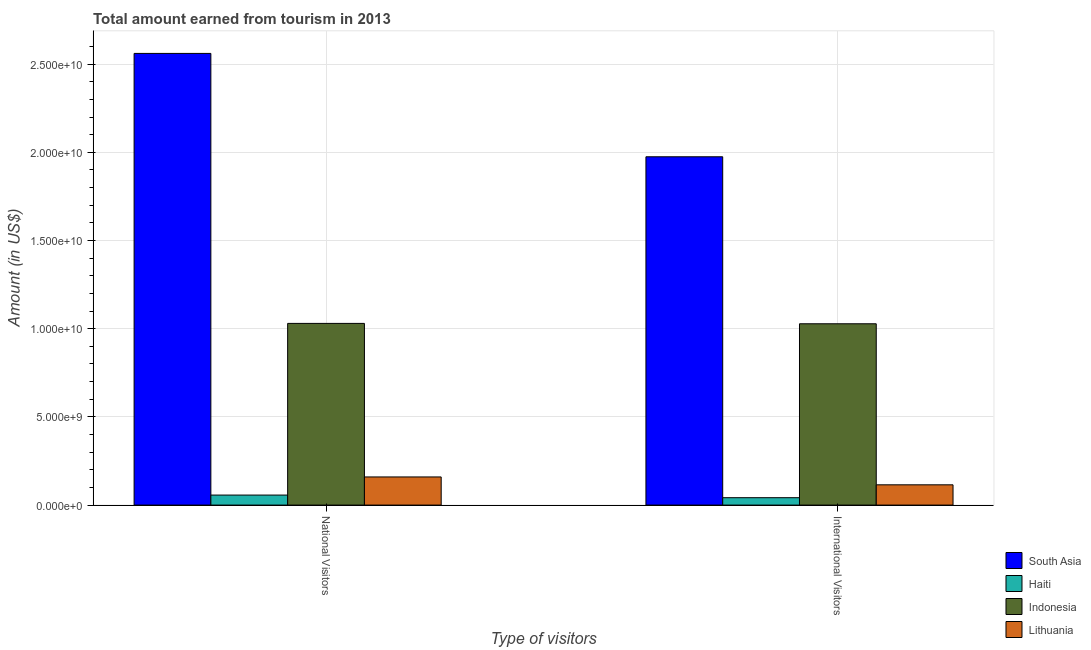How many different coloured bars are there?
Your response must be concise. 4. Are the number of bars on each tick of the X-axis equal?
Offer a very short reply. Yes. How many bars are there on the 1st tick from the right?
Ensure brevity in your answer.  4. What is the label of the 1st group of bars from the left?
Provide a succinct answer. National Visitors. What is the amount earned from national visitors in Haiti?
Keep it short and to the point. 5.68e+08. Across all countries, what is the maximum amount earned from national visitors?
Your answer should be compact. 2.56e+1. Across all countries, what is the minimum amount earned from international visitors?
Ensure brevity in your answer.  4.19e+08. In which country was the amount earned from national visitors maximum?
Make the answer very short. South Asia. In which country was the amount earned from international visitors minimum?
Make the answer very short. Haiti. What is the total amount earned from national visitors in the graph?
Ensure brevity in your answer.  3.81e+1. What is the difference between the amount earned from national visitors in South Asia and that in Lithuania?
Provide a short and direct response. 2.40e+1. What is the difference between the amount earned from international visitors in Lithuania and the amount earned from national visitors in Indonesia?
Make the answer very short. -9.15e+09. What is the average amount earned from international visitors per country?
Offer a terse response. 7.90e+09. What is the difference between the amount earned from international visitors and amount earned from national visitors in Haiti?
Your answer should be compact. -1.49e+08. What is the ratio of the amount earned from national visitors in Lithuania to that in Haiti?
Your response must be concise. 2.81. In how many countries, is the amount earned from national visitors greater than the average amount earned from national visitors taken over all countries?
Offer a very short reply. 2. What does the 4th bar from the right in National Visitors represents?
Give a very brief answer. South Asia. How many bars are there?
Your response must be concise. 8. Are the values on the major ticks of Y-axis written in scientific E-notation?
Offer a very short reply. Yes. Does the graph contain grids?
Provide a short and direct response. Yes. How are the legend labels stacked?
Ensure brevity in your answer.  Vertical. What is the title of the graph?
Give a very brief answer. Total amount earned from tourism in 2013. Does "East Asia (all income levels)" appear as one of the legend labels in the graph?
Your answer should be very brief. No. What is the label or title of the X-axis?
Your response must be concise. Type of visitors. What is the Amount (in US$) in South Asia in National Visitors?
Make the answer very short. 2.56e+1. What is the Amount (in US$) in Haiti in National Visitors?
Offer a very short reply. 5.68e+08. What is the Amount (in US$) of Indonesia in National Visitors?
Provide a succinct answer. 1.03e+1. What is the Amount (in US$) in Lithuania in National Visitors?
Your answer should be very brief. 1.60e+09. What is the Amount (in US$) in South Asia in International Visitors?
Your response must be concise. 1.97e+1. What is the Amount (in US$) in Haiti in International Visitors?
Offer a terse response. 4.19e+08. What is the Amount (in US$) in Indonesia in International Visitors?
Ensure brevity in your answer.  1.03e+1. What is the Amount (in US$) in Lithuania in International Visitors?
Give a very brief answer. 1.15e+09. Across all Type of visitors, what is the maximum Amount (in US$) of South Asia?
Your answer should be very brief. 2.56e+1. Across all Type of visitors, what is the maximum Amount (in US$) in Haiti?
Your answer should be very brief. 5.68e+08. Across all Type of visitors, what is the maximum Amount (in US$) of Indonesia?
Your answer should be very brief. 1.03e+1. Across all Type of visitors, what is the maximum Amount (in US$) in Lithuania?
Your answer should be compact. 1.60e+09. Across all Type of visitors, what is the minimum Amount (in US$) in South Asia?
Offer a terse response. 1.97e+1. Across all Type of visitors, what is the minimum Amount (in US$) in Haiti?
Your response must be concise. 4.19e+08. Across all Type of visitors, what is the minimum Amount (in US$) of Indonesia?
Your answer should be compact. 1.03e+1. Across all Type of visitors, what is the minimum Amount (in US$) of Lithuania?
Offer a very short reply. 1.15e+09. What is the total Amount (in US$) in South Asia in the graph?
Your response must be concise. 4.54e+1. What is the total Amount (in US$) of Haiti in the graph?
Your response must be concise. 9.87e+08. What is the total Amount (in US$) of Indonesia in the graph?
Your answer should be compact. 2.06e+1. What is the total Amount (in US$) of Lithuania in the graph?
Offer a terse response. 2.74e+09. What is the difference between the Amount (in US$) of South Asia in National Visitors and that in International Visitors?
Make the answer very short. 5.86e+09. What is the difference between the Amount (in US$) in Haiti in National Visitors and that in International Visitors?
Give a very brief answer. 1.49e+08. What is the difference between the Amount (in US$) of Indonesia in National Visitors and that in International Visitors?
Provide a succinct answer. 2.20e+07. What is the difference between the Amount (in US$) of Lithuania in National Visitors and that in International Visitors?
Provide a succinct answer. 4.46e+08. What is the difference between the Amount (in US$) of South Asia in National Visitors and the Amount (in US$) of Haiti in International Visitors?
Give a very brief answer. 2.52e+1. What is the difference between the Amount (in US$) in South Asia in National Visitors and the Amount (in US$) in Indonesia in International Visitors?
Offer a very short reply. 1.53e+1. What is the difference between the Amount (in US$) of South Asia in National Visitors and the Amount (in US$) of Lithuania in International Visitors?
Your answer should be very brief. 2.45e+1. What is the difference between the Amount (in US$) in Haiti in National Visitors and the Amount (in US$) in Indonesia in International Visitors?
Your answer should be compact. -9.71e+09. What is the difference between the Amount (in US$) of Haiti in National Visitors and the Amount (in US$) of Lithuania in International Visitors?
Ensure brevity in your answer.  -5.81e+08. What is the difference between the Amount (in US$) in Indonesia in National Visitors and the Amount (in US$) in Lithuania in International Visitors?
Provide a short and direct response. 9.15e+09. What is the average Amount (in US$) of South Asia per Type of visitors?
Your answer should be very brief. 2.27e+1. What is the average Amount (in US$) of Haiti per Type of visitors?
Make the answer very short. 4.94e+08. What is the average Amount (in US$) in Indonesia per Type of visitors?
Provide a succinct answer. 1.03e+1. What is the average Amount (in US$) of Lithuania per Type of visitors?
Provide a succinct answer. 1.37e+09. What is the difference between the Amount (in US$) of South Asia and Amount (in US$) of Haiti in National Visitors?
Provide a short and direct response. 2.50e+1. What is the difference between the Amount (in US$) in South Asia and Amount (in US$) in Indonesia in National Visitors?
Provide a short and direct response. 1.53e+1. What is the difference between the Amount (in US$) of South Asia and Amount (in US$) of Lithuania in National Visitors?
Your answer should be compact. 2.40e+1. What is the difference between the Amount (in US$) in Haiti and Amount (in US$) in Indonesia in National Visitors?
Make the answer very short. -9.73e+09. What is the difference between the Amount (in US$) of Haiti and Amount (in US$) of Lithuania in National Visitors?
Your answer should be very brief. -1.03e+09. What is the difference between the Amount (in US$) in Indonesia and Amount (in US$) in Lithuania in National Visitors?
Provide a succinct answer. 8.71e+09. What is the difference between the Amount (in US$) in South Asia and Amount (in US$) in Haiti in International Visitors?
Keep it short and to the point. 1.93e+1. What is the difference between the Amount (in US$) in South Asia and Amount (in US$) in Indonesia in International Visitors?
Offer a very short reply. 9.47e+09. What is the difference between the Amount (in US$) in South Asia and Amount (in US$) in Lithuania in International Visitors?
Provide a short and direct response. 1.86e+1. What is the difference between the Amount (in US$) of Haiti and Amount (in US$) of Indonesia in International Visitors?
Offer a very short reply. -9.86e+09. What is the difference between the Amount (in US$) of Haiti and Amount (in US$) of Lithuania in International Visitors?
Your response must be concise. -7.30e+08. What is the difference between the Amount (in US$) in Indonesia and Amount (in US$) in Lithuania in International Visitors?
Offer a very short reply. 9.13e+09. What is the ratio of the Amount (in US$) in South Asia in National Visitors to that in International Visitors?
Make the answer very short. 1.3. What is the ratio of the Amount (in US$) in Haiti in National Visitors to that in International Visitors?
Give a very brief answer. 1.36. What is the ratio of the Amount (in US$) in Lithuania in National Visitors to that in International Visitors?
Your answer should be compact. 1.39. What is the difference between the highest and the second highest Amount (in US$) in South Asia?
Your answer should be compact. 5.86e+09. What is the difference between the highest and the second highest Amount (in US$) in Haiti?
Keep it short and to the point. 1.49e+08. What is the difference between the highest and the second highest Amount (in US$) in Indonesia?
Keep it short and to the point. 2.20e+07. What is the difference between the highest and the second highest Amount (in US$) in Lithuania?
Provide a succinct answer. 4.46e+08. What is the difference between the highest and the lowest Amount (in US$) of South Asia?
Your response must be concise. 5.86e+09. What is the difference between the highest and the lowest Amount (in US$) in Haiti?
Offer a terse response. 1.49e+08. What is the difference between the highest and the lowest Amount (in US$) of Indonesia?
Ensure brevity in your answer.  2.20e+07. What is the difference between the highest and the lowest Amount (in US$) in Lithuania?
Make the answer very short. 4.46e+08. 